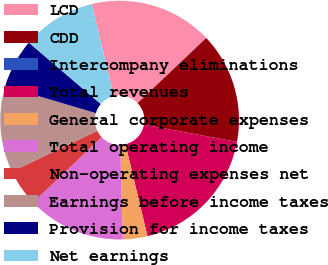Convert chart. <chart><loc_0><loc_0><loc_500><loc_500><pie_chart><fcel>LCD<fcel>CDD<fcel>Intercompany eliminations<fcel>Total revenues<fcel>General corporate expenses<fcel>Total operating income<fcel>Non-operating expenses net<fcel>Earnings before income taxes<fcel>Provision for income taxes<fcel>Net earnings<nl><fcel>16.67%<fcel>15.0%<fcel>0.0%<fcel>18.33%<fcel>3.33%<fcel>13.33%<fcel>5.0%<fcel>11.67%<fcel>6.67%<fcel>10.0%<nl></chart> 